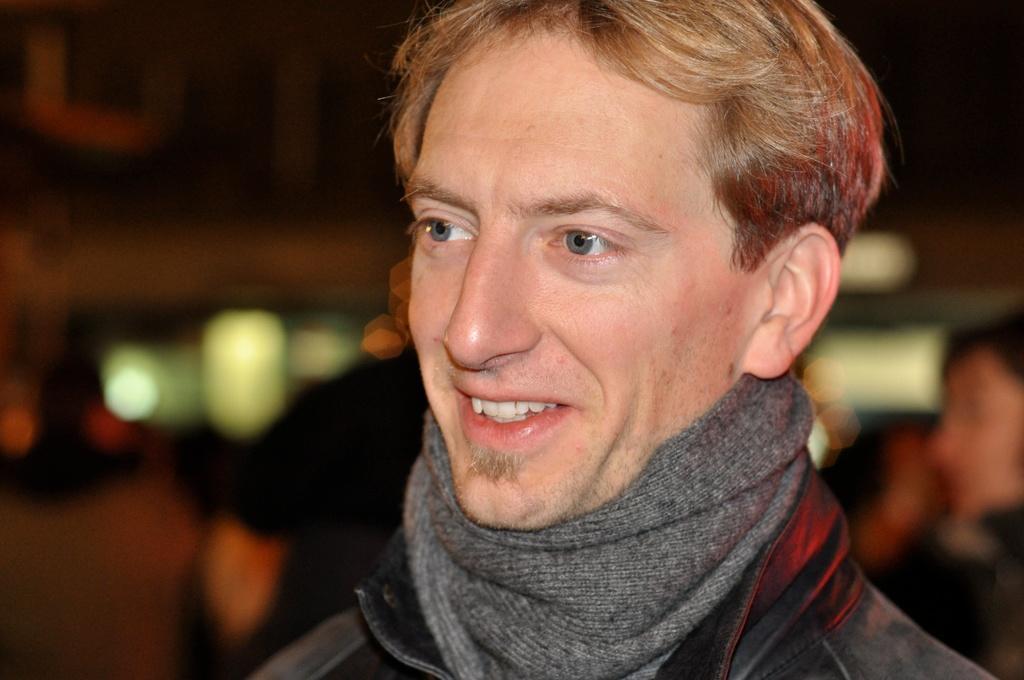Please provide a concise description of this image. In the image we can see a man, he is smiling. Behind him few people are standing. Background of the image is blur. 